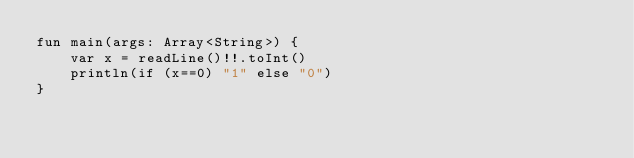<code> <loc_0><loc_0><loc_500><loc_500><_Kotlin_>fun main(args: Array<String>) {
    var x = readLine()!!.toInt()
    println(if (x==0) "1" else "0")
}</code> 